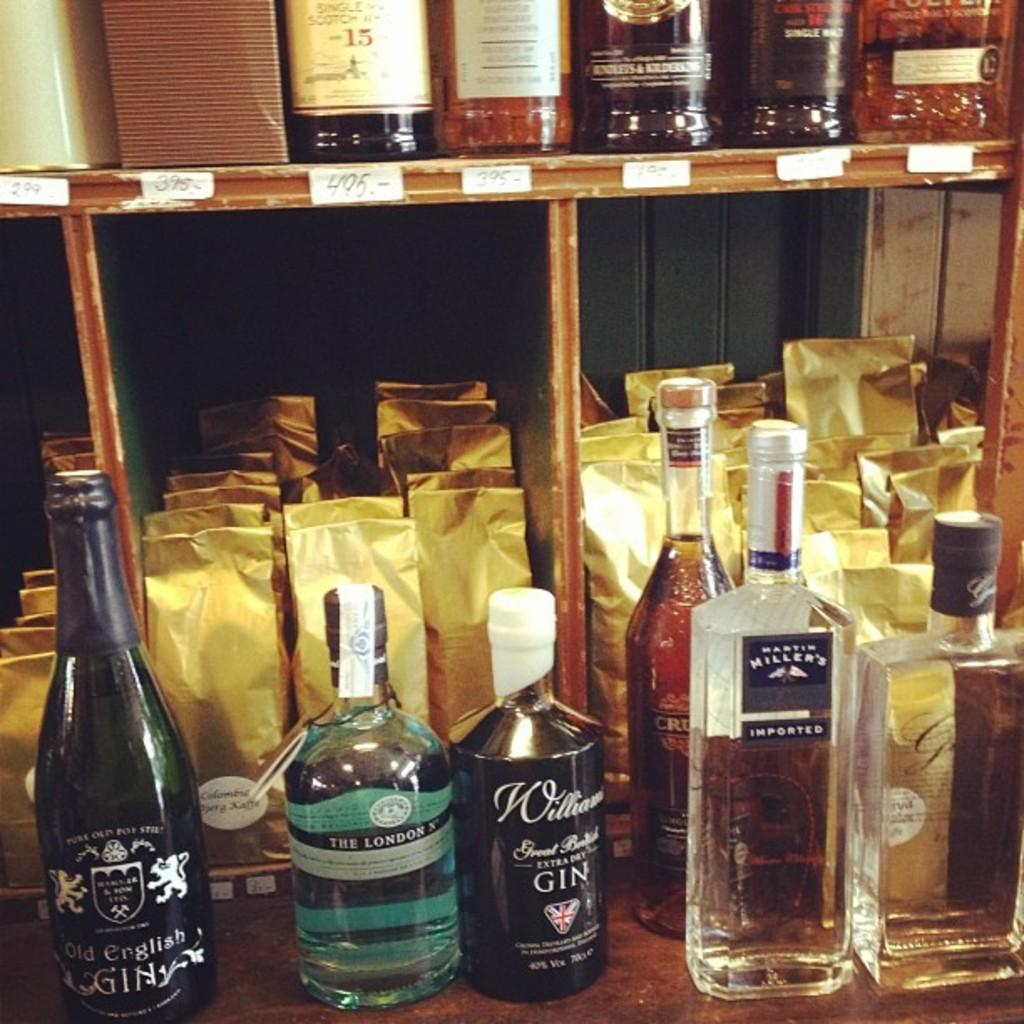<image>
Relay a brief, clear account of the picture shown. A row of liquor bottles say Old English Gin. 